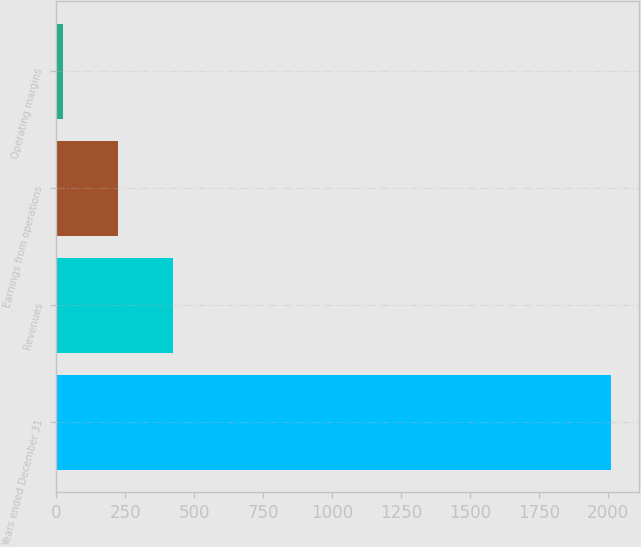Convert chart to OTSL. <chart><loc_0><loc_0><loc_500><loc_500><bar_chart><fcel>Years ended December 31<fcel>Revenues<fcel>Earnings from operations<fcel>Operating margins<nl><fcel>2013<fcel>423.4<fcel>224.7<fcel>26<nl></chart> 